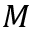Convert formula to latex. <formula><loc_0><loc_0><loc_500><loc_500>M</formula> 